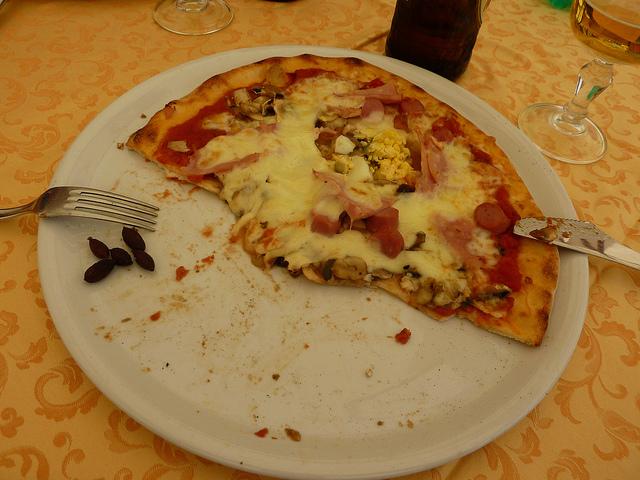Does this meal have nuts in it?
Answer briefly. No. How much of the pizza is missing?
Write a very short answer. Half. How many knives are there?
Write a very short answer. 1. How many slices of pizza are there?
Concise answer only. 1. What kind of pizza is this?
Write a very short answer. Meat thin crust. Is this Chinese food?
Quick response, please. No. How many teeth are on the plate?
Keep it brief. 0. What's in the bottle next to the plate?
Concise answer only. Beer. What food is left over?
Be succinct. Pizza. What color is the plate?
Quick response, please. White. Is this a healthy meal?
Concise answer only. No. What food is on the plate?
Keep it brief. Pizza. Has anyone eaten any yet?
Write a very short answer. Yes. What is in the plate?
Concise answer only. Pizza. Is this pizza?
Answer briefly. Yes. Where are the olive pits?
Concise answer only. On left side of plate. How many utensils can be seen?
Quick response, please. 2. What is being used to cut the pizza?
Give a very brief answer. Knife. 